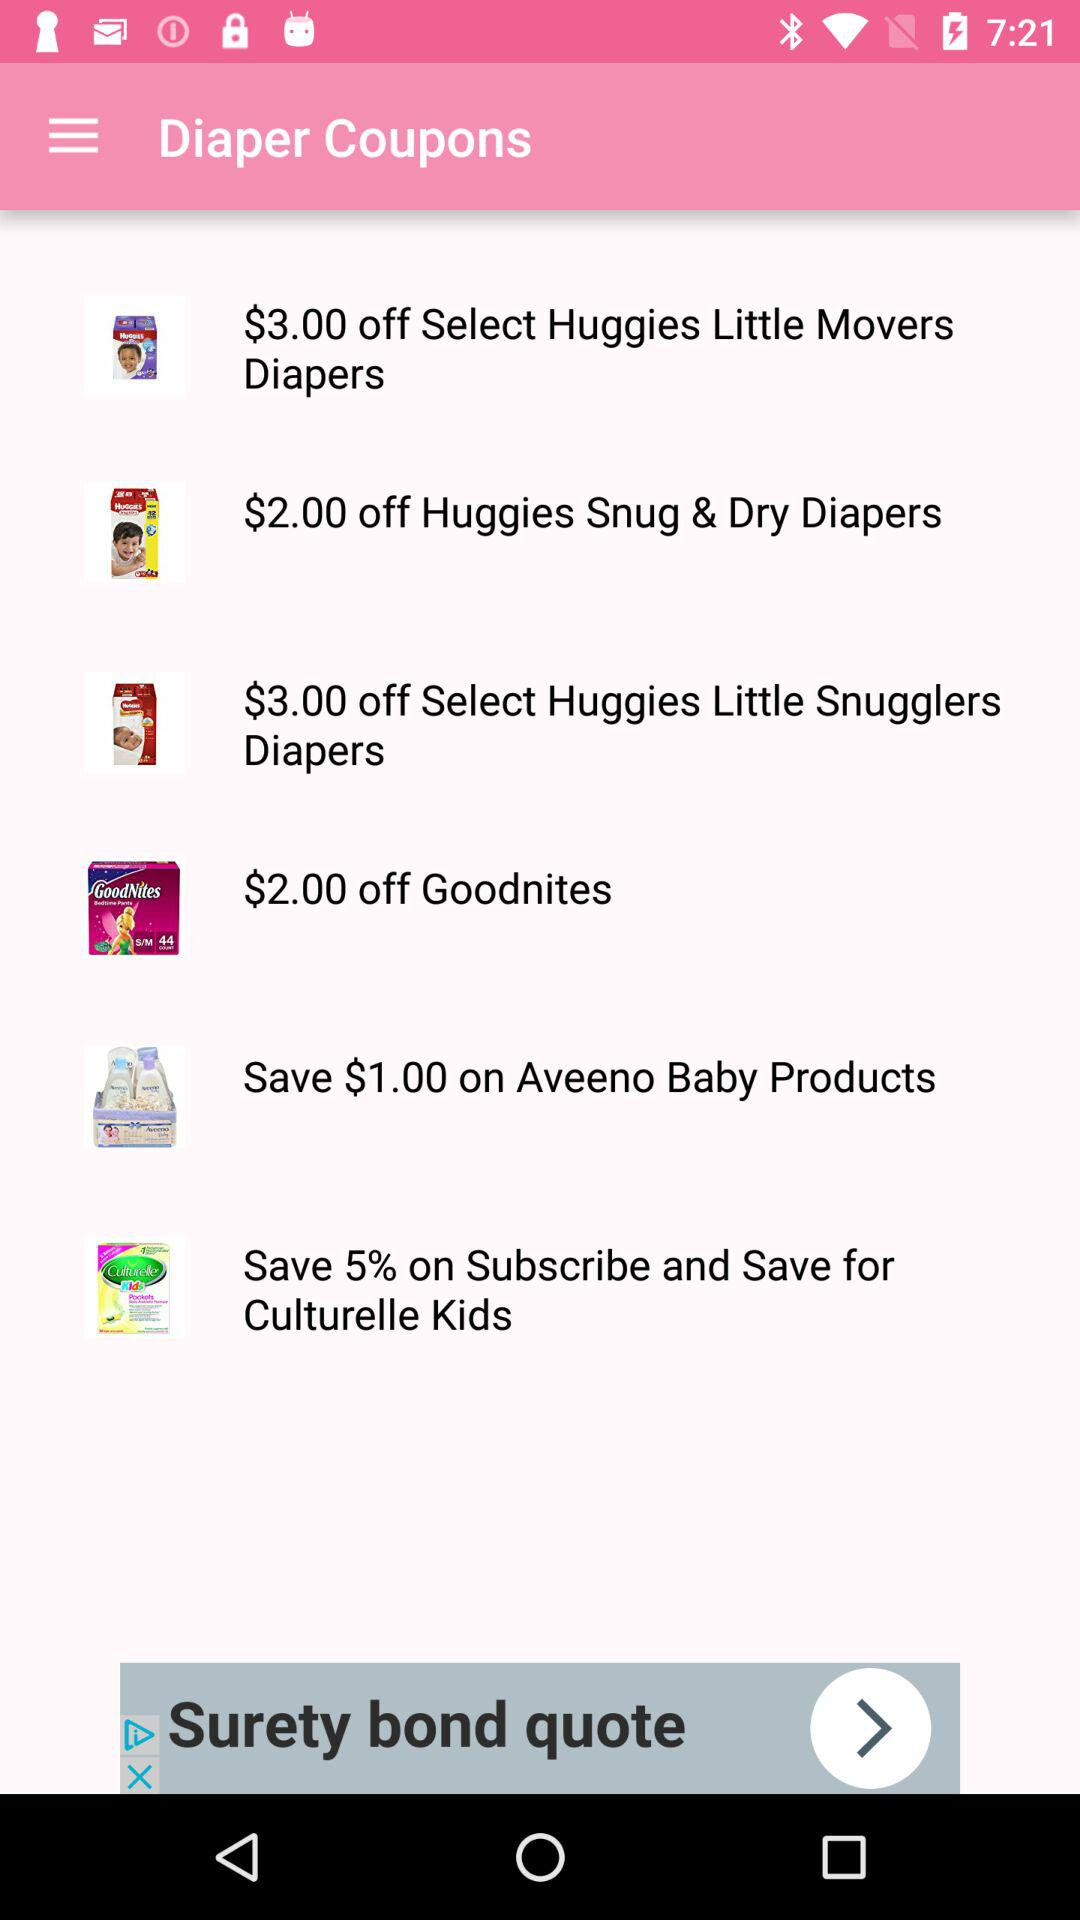How much is off on "Goodnites"? "Goodnites" has $2.00 off. 